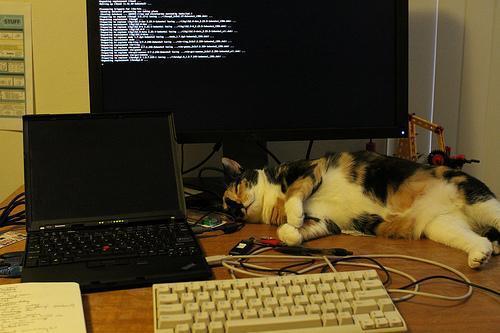How many computers are in the picture?
Give a very brief answer. 2. 